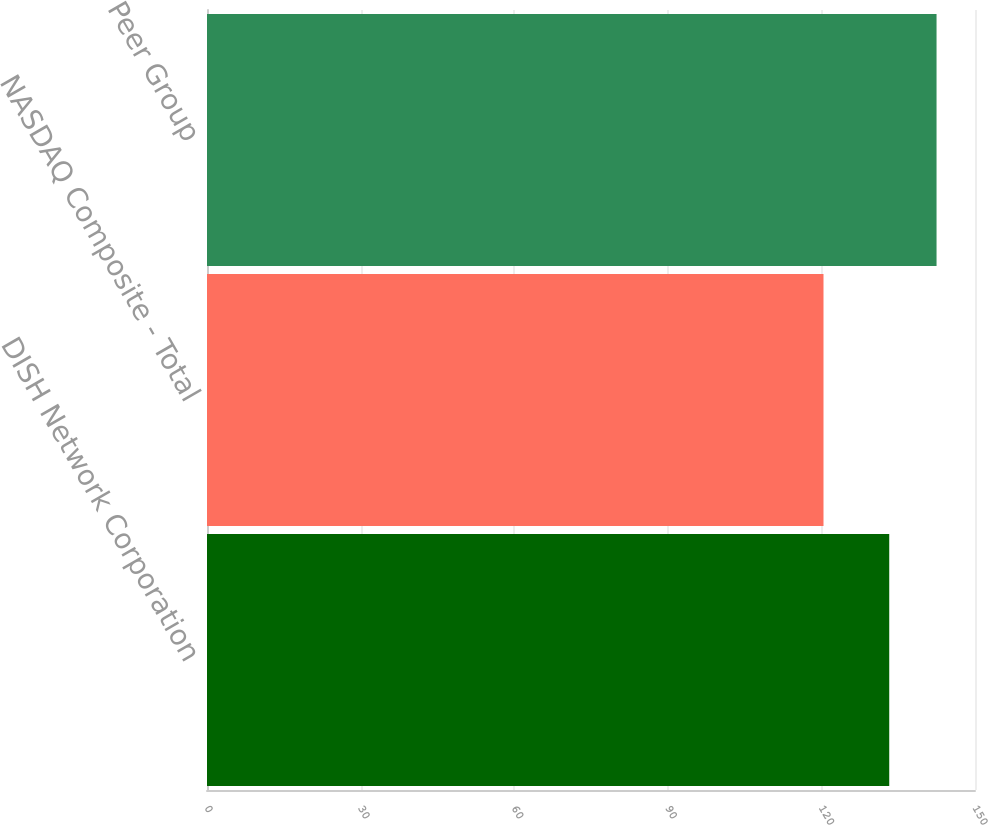Convert chart to OTSL. <chart><loc_0><loc_0><loc_500><loc_500><bar_chart><fcel>DISH Network Corporation<fcel>NASDAQ Composite - Total<fcel>Peer Group<nl><fcel>133.25<fcel>120.41<fcel>142.49<nl></chart> 